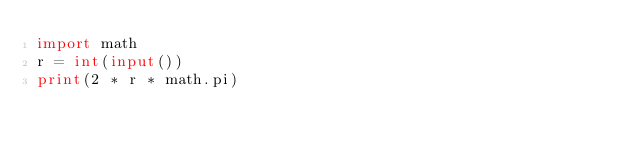Convert code to text. <code><loc_0><loc_0><loc_500><loc_500><_Python_>import math
r = int(input())
print(2 * r * math.pi)
</code> 